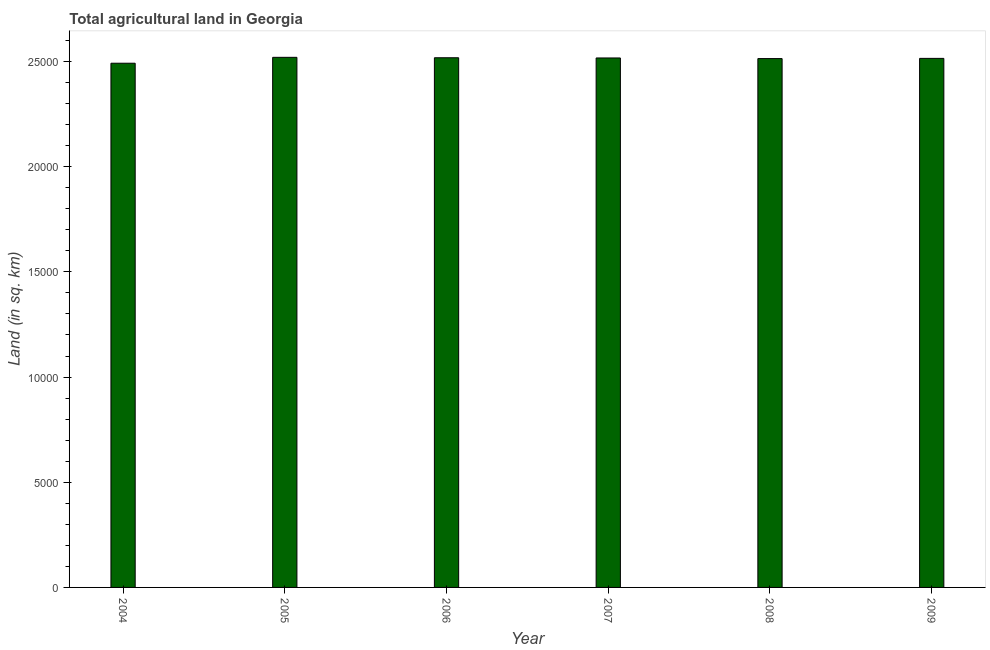Does the graph contain any zero values?
Provide a succinct answer. No. Does the graph contain grids?
Offer a very short reply. No. What is the title of the graph?
Your answer should be very brief. Total agricultural land in Georgia. What is the label or title of the X-axis?
Your answer should be compact. Year. What is the label or title of the Y-axis?
Make the answer very short. Land (in sq. km). What is the agricultural land in 2006?
Offer a terse response. 2.52e+04. Across all years, what is the maximum agricultural land?
Offer a very short reply. 2.52e+04. Across all years, what is the minimum agricultural land?
Your answer should be very brief. 2.49e+04. In which year was the agricultural land minimum?
Offer a terse response. 2004. What is the sum of the agricultural land?
Make the answer very short. 1.51e+05. What is the difference between the agricultural land in 2007 and 2008?
Make the answer very short. 30. What is the average agricultural land per year?
Your answer should be compact. 2.51e+04. What is the median agricultural land?
Provide a succinct answer. 2.52e+04. Is the agricultural land in 2007 less than that in 2009?
Give a very brief answer. No. Is the difference between the agricultural land in 2004 and 2006 greater than the difference between any two years?
Ensure brevity in your answer.  No. What is the difference between the highest and the second highest agricultural land?
Offer a very short reply. 20. Is the sum of the agricultural land in 2006 and 2007 greater than the maximum agricultural land across all years?
Offer a terse response. Yes. What is the difference between the highest and the lowest agricultural land?
Make the answer very short. 280. Are all the bars in the graph horizontal?
Ensure brevity in your answer.  No. How many years are there in the graph?
Provide a succinct answer. 6. Are the values on the major ticks of Y-axis written in scientific E-notation?
Offer a terse response. No. What is the Land (in sq. km) of 2004?
Provide a short and direct response. 2.49e+04. What is the Land (in sq. km) in 2005?
Make the answer very short. 2.52e+04. What is the Land (in sq. km) of 2006?
Give a very brief answer. 2.52e+04. What is the Land (in sq. km) in 2007?
Your answer should be compact. 2.52e+04. What is the Land (in sq. km) in 2008?
Provide a short and direct response. 2.51e+04. What is the Land (in sq. km) of 2009?
Your response must be concise. 2.52e+04. What is the difference between the Land (in sq. km) in 2004 and 2005?
Make the answer very short. -280. What is the difference between the Land (in sq. km) in 2004 and 2006?
Your answer should be compact. -260. What is the difference between the Land (in sq. km) in 2004 and 2007?
Make the answer very short. -250. What is the difference between the Land (in sq. km) in 2004 and 2008?
Your answer should be compact. -220. What is the difference between the Land (in sq. km) in 2004 and 2009?
Offer a terse response. -230. What is the difference between the Land (in sq. km) in 2005 and 2006?
Provide a succinct answer. 20. What is the difference between the Land (in sq. km) in 2005 and 2008?
Make the answer very short. 60. What is the difference between the Land (in sq. km) in 2005 and 2009?
Your answer should be compact. 50. What is the difference between the Land (in sq. km) in 2006 and 2009?
Ensure brevity in your answer.  30. What is the difference between the Land (in sq. km) in 2007 and 2008?
Offer a terse response. 30. What is the difference between the Land (in sq. km) in 2007 and 2009?
Provide a short and direct response. 20. What is the difference between the Land (in sq. km) in 2008 and 2009?
Provide a short and direct response. -10. What is the ratio of the Land (in sq. km) in 2004 to that in 2007?
Offer a very short reply. 0.99. What is the ratio of the Land (in sq. km) in 2004 to that in 2008?
Your answer should be very brief. 0.99. What is the ratio of the Land (in sq. km) in 2004 to that in 2009?
Your answer should be very brief. 0.99. What is the ratio of the Land (in sq. km) in 2005 to that in 2008?
Your answer should be very brief. 1. What is the ratio of the Land (in sq. km) in 2006 to that in 2008?
Offer a terse response. 1. What is the ratio of the Land (in sq. km) in 2006 to that in 2009?
Provide a succinct answer. 1. What is the ratio of the Land (in sq. km) in 2007 to that in 2009?
Provide a succinct answer. 1. 